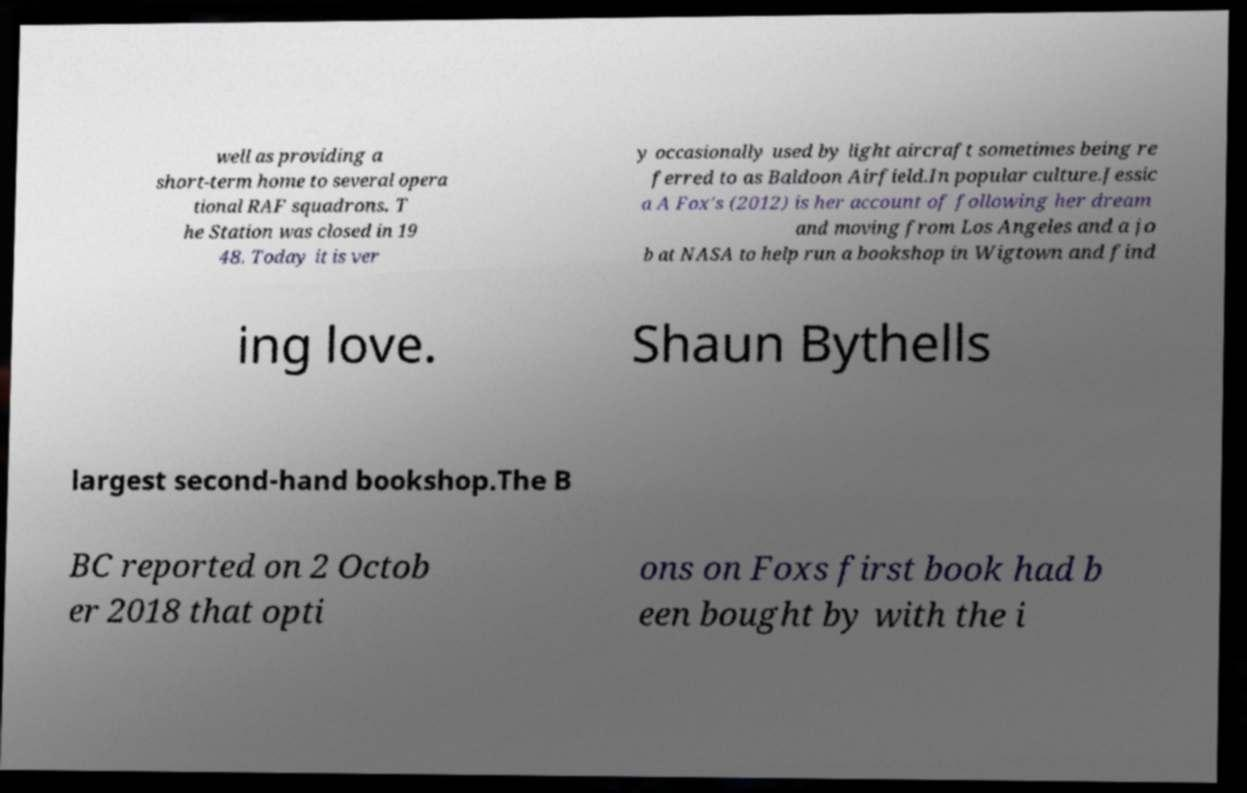What messages or text are displayed in this image? I need them in a readable, typed format. well as providing a short-term home to several opera tional RAF squadrons. T he Station was closed in 19 48. Today it is ver y occasionally used by light aircraft sometimes being re ferred to as Baldoon Airfield.In popular culture.Jessic a A Fox's (2012) is her account of following her dream and moving from Los Angeles and a jo b at NASA to help run a bookshop in Wigtown and find ing love. Shaun Bythells largest second-hand bookshop.The B BC reported on 2 Octob er 2018 that opti ons on Foxs first book had b een bought by with the i 